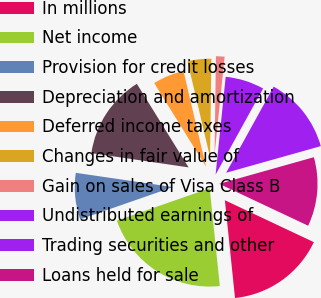Convert chart. <chart><loc_0><loc_0><loc_500><loc_500><pie_chart><fcel>In millions<fcel>Net income<fcel>Provision for credit losses<fcel>Depreciation and amortization<fcel>Deferred income taxes<fcel>Changes in fair value of<fcel>Gain on sales of Visa Class B<fcel>Undistributed earnings of<fcel>Trading securities and other<fcel>Loans held for sale<nl><fcel>16.35%<fcel>21.32%<fcel>7.64%<fcel>13.86%<fcel>5.15%<fcel>3.9%<fcel>1.41%<fcel>6.39%<fcel>12.61%<fcel>11.37%<nl></chart> 